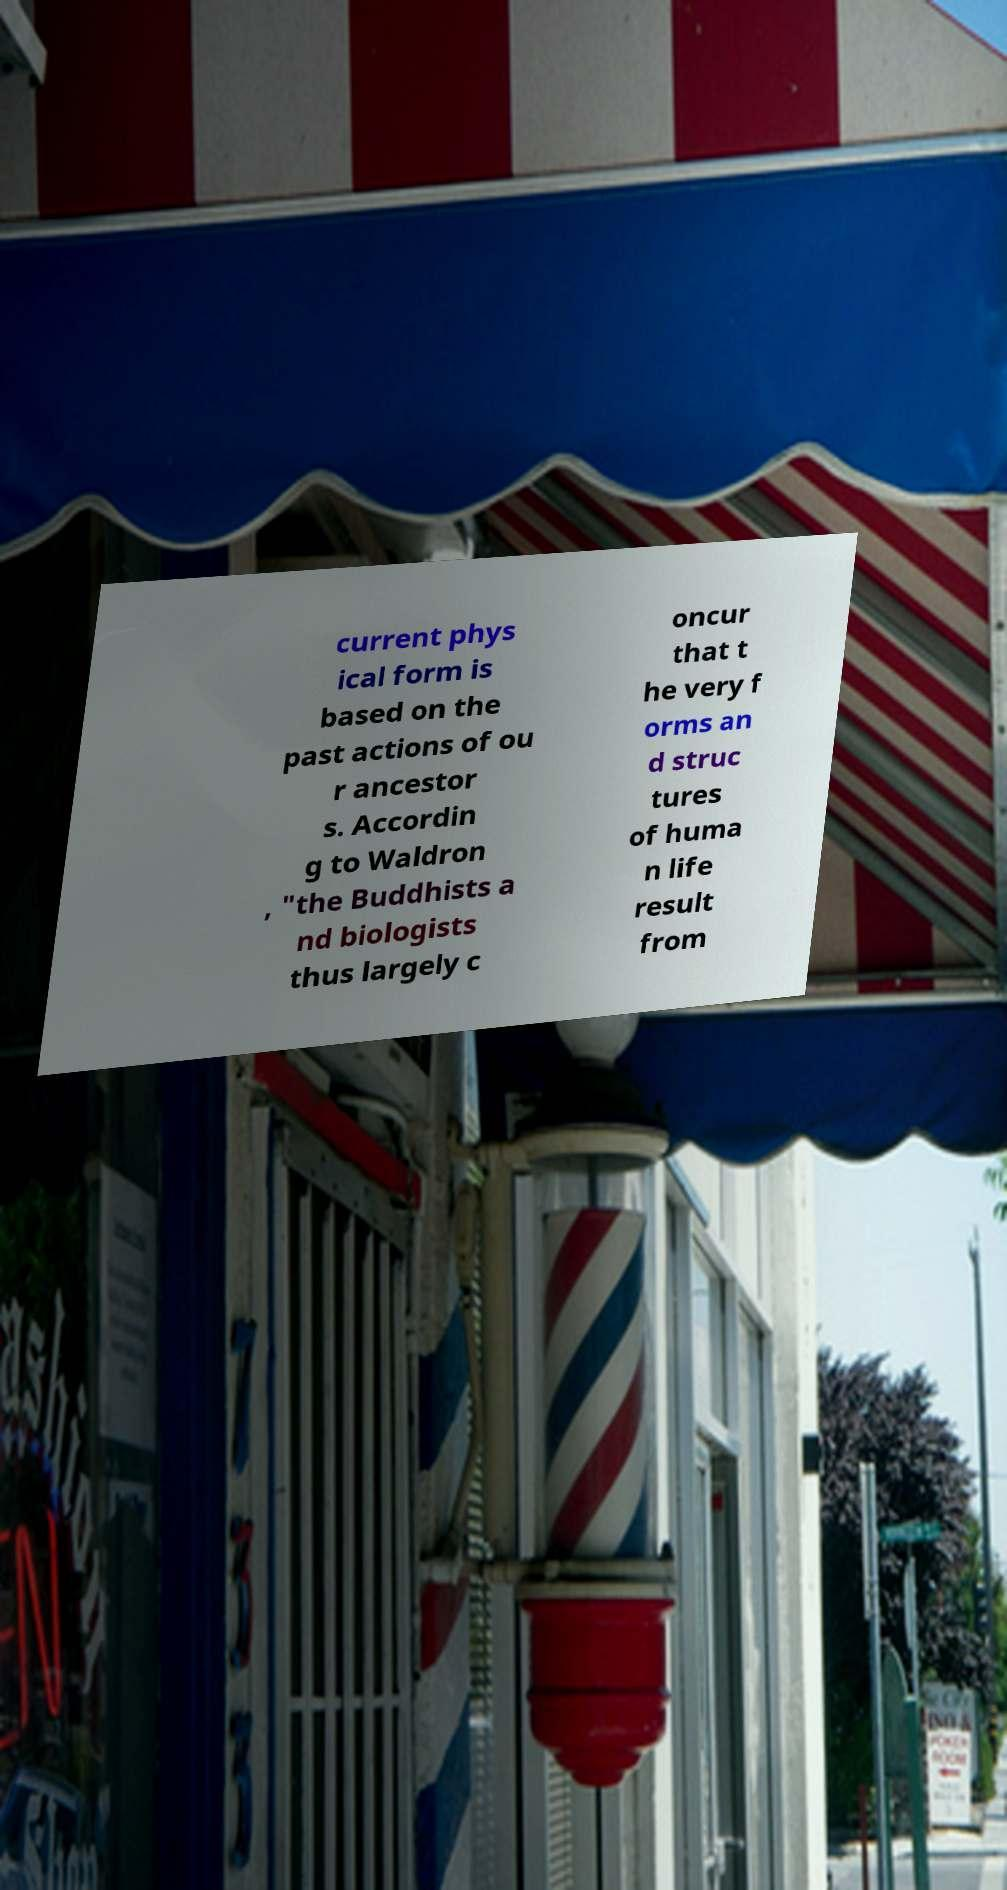Please read and relay the text visible in this image. What does it say? current phys ical form is based on the past actions of ou r ancestor s. Accordin g to Waldron , "the Buddhists a nd biologists thus largely c oncur that t he very f orms an d struc tures of huma n life result from 